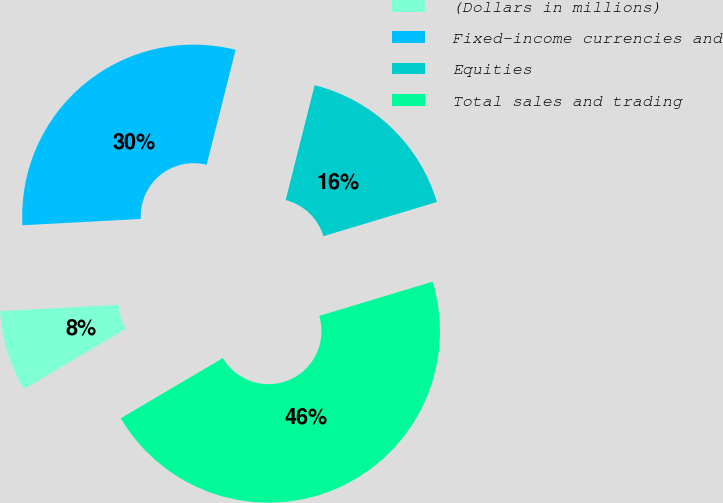<chart> <loc_0><loc_0><loc_500><loc_500><pie_chart><fcel>(Dollars in millions)<fcel>Fixed-income currencies and<fcel>Equities<fcel>Total sales and trading<nl><fcel>7.63%<fcel>29.78%<fcel>16.41%<fcel>46.19%<nl></chart> 